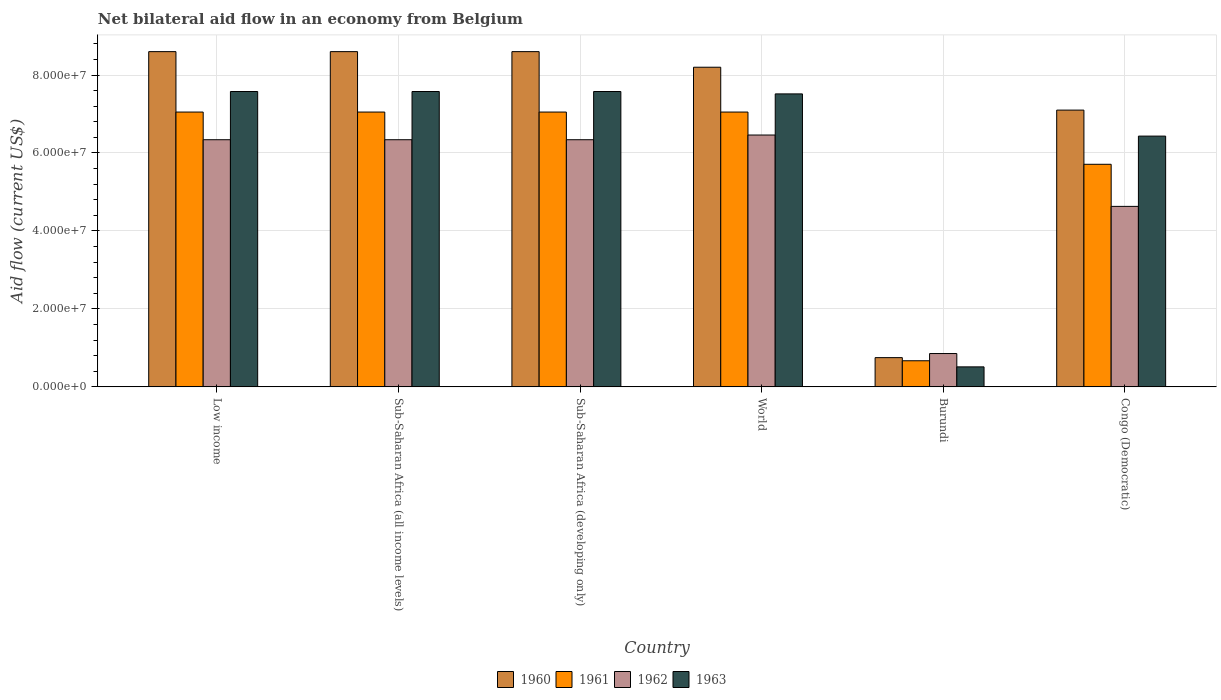How many different coloured bars are there?
Offer a terse response. 4. How many groups of bars are there?
Keep it short and to the point. 6. Are the number of bars per tick equal to the number of legend labels?
Your answer should be very brief. Yes. How many bars are there on the 3rd tick from the left?
Make the answer very short. 4. How many bars are there on the 3rd tick from the right?
Make the answer very short. 4. What is the label of the 2nd group of bars from the left?
Offer a terse response. Sub-Saharan Africa (all income levels). In how many cases, is the number of bars for a given country not equal to the number of legend labels?
Provide a short and direct response. 0. What is the net bilateral aid flow in 1963 in Congo (Democratic)?
Provide a short and direct response. 6.43e+07. Across all countries, what is the maximum net bilateral aid flow in 1963?
Your answer should be very brief. 7.58e+07. Across all countries, what is the minimum net bilateral aid flow in 1962?
Your response must be concise. 8.55e+06. In which country was the net bilateral aid flow in 1961 maximum?
Your answer should be compact. Low income. In which country was the net bilateral aid flow in 1962 minimum?
Keep it short and to the point. Burundi. What is the total net bilateral aid flow in 1963 in the graph?
Your answer should be very brief. 3.72e+08. What is the difference between the net bilateral aid flow in 1961 in Congo (Democratic) and that in Sub-Saharan Africa (developing only)?
Offer a very short reply. -1.34e+07. What is the difference between the net bilateral aid flow in 1960 in Congo (Democratic) and the net bilateral aid flow in 1963 in Low income?
Your response must be concise. -4.77e+06. What is the average net bilateral aid flow in 1962 per country?
Provide a succinct answer. 5.16e+07. What is the difference between the net bilateral aid flow of/in 1962 and net bilateral aid flow of/in 1963 in Low income?
Keep it short and to the point. -1.24e+07. What is the ratio of the net bilateral aid flow in 1960 in Sub-Saharan Africa (all income levels) to that in World?
Keep it short and to the point. 1.05. Is the difference between the net bilateral aid flow in 1962 in Low income and Sub-Saharan Africa (developing only) greater than the difference between the net bilateral aid flow in 1963 in Low income and Sub-Saharan Africa (developing only)?
Make the answer very short. No. What is the difference between the highest and the second highest net bilateral aid flow in 1962?
Give a very brief answer. 1.21e+06. What is the difference between the highest and the lowest net bilateral aid flow in 1961?
Ensure brevity in your answer.  6.38e+07. What does the 4th bar from the left in Low income represents?
Your answer should be compact. 1963. Is it the case that in every country, the sum of the net bilateral aid flow in 1961 and net bilateral aid flow in 1962 is greater than the net bilateral aid flow in 1963?
Offer a very short reply. Yes. How many bars are there?
Make the answer very short. 24. How many countries are there in the graph?
Your answer should be compact. 6. Does the graph contain any zero values?
Your answer should be very brief. No. Where does the legend appear in the graph?
Provide a succinct answer. Bottom center. How are the legend labels stacked?
Your answer should be compact. Horizontal. What is the title of the graph?
Provide a short and direct response. Net bilateral aid flow in an economy from Belgium. Does "2006" appear as one of the legend labels in the graph?
Make the answer very short. No. What is the Aid flow (current US$) in 1960 in Low income?
Offer a terse response. 8.60e+07. What is the Aid flow (current US$) of 1961 in Low income?
Make the answer very short. 7.05e+07. What is the Aid flow (current US$) in 1962 in Low income?
Offer a terse response. 6.34e+07. What is the Aid flow (current US$) of 1963 in Low income?
Offer a terse response. 7.58e+07. What is the Aid flow (current US$) in 1960 in Sub-Saharan Africa (all income levels)?
Your answer should be compact. 8.60e+07. What is the Aid flow (current US$) of 1961 in Sub-Saharan Africa (all income levels)?
Keep it short and to the point. 7.05e+07. What is the Aid flow (current US$) of 1962 in Sub-Saharan Africa (all income levels)?
Provide a succinct answer. 6.34e+07. What is the Aid flow (current US$) in 1963 in Sub-Saharan Africa (all income levels)?
Make the answer very short. 7.58e+07. What is the Aid flow (current US$) of 1960 in Sub-Saharan Africa (developing only)?
Offer a terse response. 8.60e+07. What is the Aid flow (current US$) in 1961 in Sub-Saharan Africa (developing only)?
Make the answer very short. 7.05e+07. What is the Aid flow (current US$) of 1962 in Sub-Saharan Africa (developing only)?
Your answer should be very brief. 6.34e+07. What is the Aid flow (current US$) of 1963 in Sub-Saharan Africa (developing only)?
Your answer should be compact. 7.58e+07. What is the Aid flow (current US$) of 1960 in World?
Ensure brevity in your answer.  8.20e+07. What is the Aid flow (current US$) in 1961 in World?
Give a very brief answer. 7.05e+07. What is the Aid flow (current US$) of 1962 in World?
Ensure brevity in your answer.  6.46e+07. What is the Aid flow (current US$) of 1963 in World?
Keep it short and to the point. 7.52e+07. What is the Aid flow (current US$) of 1960 in Burundi?
Keep it short and to the point. 7.50e+06. What is the Aid flow (current US$) of 1961 in Burundi?
Provide a succinct answer. 6.70e+06. What is the Aid flow (current US$) of 1962 in Burundi?
Your answer should be very brief. 8.55e+06. What is the Aid flow (current US$) of 1963 in Burundi?
Ensure brevity in your answer.  5.13e+06. What is the Aid flow (current US$) of 1960 in Congo (Democratic)?
Give a very brief answer. 7.10e+07. What is the Aid flow (current US$) in 1961 in Congo (Democratic)?
Provide a succinct answer. 5.71e+07. What is the Aid flow (current US$) in 1962 in Congo (Democratic)?
Provide a short and direct response. 4.63e+07. What is the Aid flow (current US$) of 1963 in Congo (Democratic)?
Provide a short and direct response. 6.43e+07. Across all countries, what is the maximum Aid flow (current US$) of 1960?
Provide a succinct answer. 8.60e+07. Across all countries, what is the maximum Aid flow (current US$) of 1961?
Your answer should be compact. 7.05e+07. Across all countries, what is the maximum Aid flow (current US$) in 1962?
Make the answer very short. 6.46e+07. Across all countries, what is the maximum Aid flow (current US$) in 1963?
Provide a short and direct response. 7.58e+07. Across all countries, what is the minimum Aid flow (current US$) of 1960?
Make the answer very short. 7.50e+06. Across all countries, what is the minimum Aid flow (current US$) of 1961?
Make the answer very short. 6.70e+06. Across all countries, what is the minimum Aid flow (current US$) of 1962?
Keep it short and to the point. 8.55e+06. Across all countries, what is the minimum Aid flow (current US$) in 1963?
Give a very brief answer. 5.13e+06. What is the total Aid flow (current US$) in 1960 in the graph?
Provide a succinct answer. 4.18e+08. What is the total Aid flow (current US$) in 1961 in the graph?
Give a very brief answer. 3.46e+08. What is the total Aid flow (current US$) in 1962 in the graph?
Ensure brevity in your answer.  3.10e+08. What is the total Aid flow (current US$) of 1963 in the graph?
Provide a short and direct response. 3.72e+08. What is the difference between the Aid flow (current US$) in 1960 in Low income and that in Sub-Saharan Africa (all income levels)?
Your response must be concise. 0. What is the difference between the Aid flow (current US$) in 1961 in Low income and that in Sub-Saharan Africa (all income levels)?
Your answer should be compact. 0. What is the difference between the Aid flow (current US$) in 1961 in Low income and that in Sub-Saharan Africa (developing only)?
Your answer should be compact. 0. What is the difference between the Aid flow (current US$) in 1961 in Low income and that in World?
Give a very brief answer. 0. What is the difference between the Aid flow (current US$) of 1962 in Low income and that in World?
Keep it short and to the point. -1.21e+06. What is the difference between the Aid flow (current US$) of 1960 in Low income and that in Burundi?
Offer a terse response. 7.85e+07. What is the difference between the Aid flow (current US$) in 1961 in Low income and that in Burundi?
Provide a short and direct response. 6.38e+07. What is the difference between the Aid flow (current US$) in 1962 in Low income and that in Burundi?
Provide a succinct answer. 5.48e+07. What is the difference between the Aid flow (current US$) in 1963 in Low income and that in Burundi?
Your answer should be compact. 7.06e+07. What is the difference between the Aid flow (current US$) of 1960 in Low income and that in Congo (Democratic)?
Provide a succinct answer. 1.50e+07. What is the difference between the Aid flow (current US$) of 1961 in Low income and that in Congo (Democratic)?
Your answer should be compact. 1.34e+07. What is the difference between the Aid flow (current US$) in 1962 in Low income and that in Congo (Democratic)?
Ensure brevity in your answer.  1.71e+07. What is the difference between the Aid flow (current US$) of 1963 in Low income and that in Congo (Democratic)?
Keep it short and to the point. 1.14e+07. What is the difference between the Aid flow (current US$) of 1960 in Sub-Saharan Africa (all income levels) and that in Sub-Saharan Africa (developing only)?
Your answer should be very brief. 0. What is the difference between the Aid flow (current US$) of 1961 in Sub-Saharan Africa (all income levels) and that in Sub-Saharan Africa (developing only)?
Offer a very short reply. 0. What is the difference between the Aid flow (current US$) of 1962 in Sub-Saharan Africa (all income levels) and that in World?
Keep it short and to the point. -1.21e+06. What is the difference between the Aid flow (current US$) in 1960 in Sub-Saharan Africa (all income levels) and that in Burundi?
Provide a short and direct response. 7.85e+07. What is the difference between the Aid flow (current US$) of 1961 in Sub-Saharan Africa (all income levels) and that in Burundi?
Give a very brief answer. 6.38e+07. What is the difference between the Aid flow (current US$) in 1962 in Sub-Saharan Africa (all income levels) and that in Burundi?
Provide a short and direct response. 5.48e+07. What is the difference between the Aid flow (current US$) of 1963 in Sub-Saharan Africa (all income levels) and that in Burundi?
Give a very brief answer. 7.06e+07. What is the difference between the Aid flow (current US$) in 1960 in Sub-Saharan Africa (all income levels) and that in Congo (Democratic)?
Offer a terse response. 1.50e+07. What is the difference between the Aid flow (current US$) in 1961 in Sub-Saharan Africa (all income levels) and that in Congo (Democratic)?
Make the answer very short. 1.34e+07. What is the difference between the Aid flow (current US$) in 1962 in Sub-Saharan Africa (all income levels) and that in Congo (Democratic)?
Provide a succinct answer. 1.71e+07. What is the difference between the Aid flow (current US$) in 1963 in Sub-Saharan Africa (all income levels) and that in Congo (Democratic)?
Keep it short and to the point. 1.14e+07. What is the difference between the Aid flow (current US$) of 1960 in Sub-Saharan Africa (developing only) and that in World?
Make the answer very short. 4.00e+06. What is the difference between the Aid flow (current US$) in 1961 in Sub-Saharan Africa (developing only) and that in World?
Keep it short and to the point. 0. What is the difference between the Aid flow (current US$) of 1962 in Sub-Saharan Africa (developing only) and that in World?
Provide a succinct answer. -1.21e+06. What is the difference between the Aid flow (current US$) in 1963 in Sub-Saharan Africa (developing only) and that in World?
Keep it short and to the point. 6.10e+05. What is the difference between the Aid flow (current US$) of 1960 in Sub-Saharan Africa (developing only) and that in Burundi?
Ensure brevity in your answer.  7.85e+07. What is the difference between the Aid flow (current US$) in 1961 in Sub-Saharan Africa (developing only) and that in Burundi?
Provide a succinct answer. 6.38e+07. What is the difference between the Aid flow (current US$) of 1962 in Sub-Saharan Africa (developing only) and that in Burundi?
Your answer should be compact. 5.48e+07. What is the difference between the Aid flow (current US$) in 1963 in Sub-Saharan Africa (developing only) and that in Burundi?
Provide a short and direct response. 7.06e+07. What is the difference between the Aid flow (current US$) in 1960 in Sub-Saharan Africa (developing only) and that in Congo (Democratic)?
Your answer should be compact. 1.50e+07. What is the difference between the Aid flow (current US$) in 1961 in Sub-Saharan Africa (developing only) and that in Congo (Democratic)?
Provide a succinct answer. 1.34e+07. What is the difference between the Aid flow (current US$) of 1962 in Sub-Saharan Africa (developing only) and that in Congo (Democratic)?
Make the answer very short. 1.71e+07. What is the difference between the Aid flow (current US$) of 1963 in Sub-Saharan Africa (developing only) and that in Congo (Democratic)?
Give a very brief answer. 1.14e+07. What is the difference between the Aid flow (current US$) in 1960 in World and that in Burundi?
Provide a short and direct response. 7.45e+07. What is the difference between the Aid flow (current US$) in 1961 in World and that in Burundi?
Provide a succinct answer. 6.38e+07. What is the difference between the Aid flow (current US$) of 1962 in World and that in Burundi?
Keep it short and to the point. 5.61e+07. What is the difference between the Aid flow (current US$) in 1963 in World and that in Burundi?
Provide a short and direct response. 7.00e+07. What is the difference between the Aid flow (current US$) of 1960 in World and that in Congo (Democratic)?
Your answer should be compact. 1.10e+07. What is the difference between the Aid flow (current US$) of 1961 in World and that in Congo (Democratic)?
Your answer should be very brief. 1.34e+07. What is the difference between the Aid flow (current US$) in 1962 in World and that in Congo (Democratic)?
Provide a short and direct response. 1.83e+07. What is the difference between the Aid flow (current US$) of 1963 in World and that in Congo (Democratic)?
Ensure brevity in your answer.  1.08e+07. What is the difference between the Aid flow (current US$) of 1960 in Burundi and that in Congo (Democratic)?
Your answer should be compact. -6.35e+07. What is the difference between the Aid flow (current US$) of 1961 in Burundi and that in Congo (Democratic)?
Keep it short and to the point. -5.04e+07. What is the difference between the Aid flow (current US$) in 1962 in Burundi and that in Congo (Democratic)?
Keep it short and to the point. -3.78e+07. What is the difference between the Aid flow (current US$) of 1963 in Burundi and that in Congo (Democratic)?
Your answer should be very brief. -5.92e+07. What is the difference between the Aid flow (current US$) in 1960 in Low income and the Aid flow (current US$) in 1961 in Sub-Saharan Africa (all income levels)?
Your answer should be very brief. 1.55e+07. What is the difference between the Aid flow (current US$) in 1960 in Low income and the Aid flow (current US$) in 1962 in Sub-Saharan Africa (all income levels)?
Make the answer very short. 2.26e+07. What is the difference between the Aid flow (current US$) in 1960 in Low income and the Aid flow (current US$) in 1963 in Sub-Saharan Africa (all income levels)?
Offer a very short reply. 1.02e+07. What is the difference between the Aid flow (current US$) of 1961 in Low income and the Aid flow (current US$) of 1962 in Sub-Saharan Africa (all income levels)?
Offer a terse response. 7.10e+06. What is the difference between the Aid flow (current US$) in 1961 in Low income and the Aid flow (current US$) in 1963 in Sub-Saharan Africa (all income levels)?
Offer a terse response. -5.27e+06. What is the difference between the Aid flow (current US$) of 1962 in Low income and the Aid flow (current US$) of 1963 in Sub-Saharan Africa (all income levels)?
Your response must be concise. -1.24e+07. What is the difference between the Aid flow (current US$) in 1960 in Low income and the Aid flow (current US$) in 1961 in Sub-Saharan Africa (developing only)?
Give a very brief answer. 1.55e+07. What is the difference between the Aid flow (current US$) in 1960 in Low income and the Aid flow (current US$) in 1962 in Sub-Saharan Africa (developing only)?
Provide a succinct answer. 2.26e+07. What is the difference between the Aid flow (current US$) of 1960 in Low income and the Aid flow (current US$) of 1963 in Sub-Saharan Africa (developing only)?
Give a very brief answer. 1.02e+07. What is the difference between the Aid flow (current US$) of 1961 in Low income and the Aid flow (current US$) of 1962 in Sub-Saharan Africa (developing only)?
Provide a short and direct response. 7.10e+06. What is the difference between the Aid flow (current US$) of 1961 in Low income and the Aid flow (current US$) of 1963 in Sub-Saharan Africa (developing only)?
Your answer should be compact. -5.27e+06. What is the difference between the Aid flow (current US$) of 1962 in Low income and the Aid flow (current US$) of 1963 in Sub-Saharan Africa (developing only)?
Provide a short and direct response. -1.24e+07. What is the difference between the Aid flow (current US$) of 1960 in Low income and the Aid flow (current US$) of 1961 in World?
Provide a succinct answer. 1.55e+07. What is the difference between the Aid flow (current US$) in 1960 in Low income and the Aid flow (current US$) in 1962 in World?
Your response must be concise. 2.14e+07. What is the difference between the Aid flow (current US$) in 1960 in Low income and the Aid flow (current US$) in 1963 in World?
Your answer should be very brief. 1.08e+07. What is the difference between the Aid flow (current US$) in 1961 in Low income and the Aid flow (current US$) in 1962 in World?
Your response must be concise. 5.89e+06. What is the difference between the Aid flow (current US$) of 1961 in Low income and the Aid flow (current US$) of 1963 in World?
Offer a terse response. -4.66e+06. What is the difference between the Aid flow (current US$) in 1962 in Low income and the Aid flow (current US$) in 1963 in World?
Make the answer very short. -1.18e+07. What is the difference between the Aid flow (current US$) of 1960 in Low income and the Aid flow (current US$) of 1961 in Burundi?
Give a very brief answer. 7.93e+07. What is the difference between the Aid flow (current US$) of 1960 in Low income and the Aid flow (current US$) of 1962 in Burundi?
Your response must be concise. 7.74e+07. What is the difference between the Aid flow (current US$) of 1960 in Low income and the Aid flow (current US$) of 1963 in Burundi?
Your answer should be compact. 8.09e+07. What is the difference between the Aid flow (current US$) in 1961 in Low income and the Aid flow (current US$) in 1962 in Burundi?
Offer a very short reply. 6.20e+07. What is the difference between the Aid flow (current US$) of 1961 in Low income and the Aid flow (current US$) of 1963 in Burundi?
Ensure brevity in your answer.  6.54e+07. What is the difference between the Aid flow (current US$) of 1962 in Low income and the Aid flow (current US$) of 1963 in Burundi?
Make the answer very short. 5.83e+07. What is the difference between the Aid flow (current US$) of 1960 in Low income and the Aid flow (current US$) of 1961 in Congo (Democratic)?
Your answer should be very brief. 2.89e+07. What is the difference between the Aid flow (current US$) in 1960 in Low income and the Aid flow (current US$) in 1962 in Congo (Democratic)?
Offer a terse response. 3.97e+07. What is the difference between the Aid flow (current US$) in 1960 in Low income and the Aid flow (current US$) in 1963 in Congo (Democratic)?
Your response must be concise. 2.17e+07. What is the difference between the Aid flow (current US$) of 1961 in Low income and the Aid flow (current US$) of 1962 in Congo (Democratic)?
Make the answer very short. 2.42e+07. What is the difference between the Aid flow (current US$) in 1961 in Low income and the Aid flow (current US$) in 1963 in Congo (Democratic)?
Provide a succinct answer. 6.17e+06. What is the difference between the Aid flow (current US$) in 1962 in Low income and the Aid flow (current US$) in 1963 in Congo (Democratic)?
Offer a terse response. -9.30e+05. What is the difference between the Aid flow (current US$) of 1960 in Sub-Saharan Africa (all income levels) and the Aid flow (current US$) of 1961 in Sub-Saharan Africa (developing only)?
Ensure brevity in your answer.  1.55e+07. What is the difference between the Aid flow (current US$) in 1960 in Sub-Saharan Africa (all income levels) and the Aid flow (current US$) in 1962 in Sub-Saharan Africa (developing only)?
Make the answer very short. 2.26e+07. What is the difference between the Aid flow (current US$) of 1960 in Sub-Saharan Africa (all income levels) and the Aid flow (current US$) of 1963 in Sub-Saharan Africa (developing only)?
Make the answer very short. 1.02e+07. What is the difference between the Aid flow (current US$) of 1961 in Sub-Saharan Africa (all income levels) and the Aid flow (current US$) of 1962 in Sub-Saharan Africa (developing only)?
Provide a succinct answer. 7.10e+06. What is the difference between the Aid flow (current US$) of 1961 in Sub-Saharan Africa (all income levels) and the Aid flow (current US$) of 1963 in Sub-Saharan Africa (developing only)?
Offer a terse response. -5.27e+06. What is the difference between the Aid flow (current US$) of 1962 in Sub-Saharan Africa (all income levels) and the Aid flow (current US$) of 1963 in Sub-Saharan Africa (developing only)?
Keep it short and to the point. -1.24e+07. What is the difference between the Aid flow (current US$) of 1960 in Sub-Saharan Africa (all income levels) and the Aid flow (current US$) of 1961 in World?
Provide a succinct answer. 1.55e+07. What is the difference between the Aid flow (current US$) in 1960 in Sub-Saharan Africa (all income levels) and the Aid flow (current US$) in 1962 in World?
Your answer should be compact. 2.14e+07. What is the difference between the Aid flow (current US$) in 1960 in Sub-Saharan Africa (all income levels) and the Aid flow (current US$) in 1963 in World?
Make the answer very short. 1.08e+07. What is the difference between the Aid flow (current US$) of 1961 in Sub-Saharan Africa (all income levels) and the Aid flow (current US$) of 1962 in World?
Your response must be concise. 5.89e+06. What is the difference between the Aid flow (current US$) of 1961 in Sub-Saharan Africa (all income levels) and the Aid flow (current US$) of 1963 in World?
Provide a succinct answer. -4.66e+06. What is the difference between the Aid flow (current US$) in 1962 in Sub-Saharan Africa (all income levels) and the Aid flow (current US$) in 1963 in World?
Provide a short and direct response. -1.18e+07. What is the difference between the Aid flow (current US$) in 1960 in Sub-Saharan Africa (all income levels) and the Aid flow (current US$) in 1961 in Burundi?
Offer a very short reply. 7.93e+07. What is the difference between the Aid flow (current US$) in 1960 in Sub-Saharan Africa (all income levels) and the Aid flow (current US$) in 1962 in Burundi?
Offer a terse response. 7.74e+07. What is the difference between the Aid flow (current US$) of 1960 in Sub-Saharan Africa (all income levels) and the Aid flow (current US$) of 1963 in Burundi?
Offer a very short reply. 8.09e+07. What is the difference between the Aid flow (current US$) in 1961 in Sub-Saharan Africa (all income levels) and the Aid flow (current US$) in 1962 in Burundi?
Keep it short and to the point. 6.20e+07. What is the difference between the Aid flow (current US$) of 1961 in Sub-Saharan Africa (all income levels) and the Aid flow (current US$) of 1963 in Burundi?
Ensure brevity in your answer.  6.54e+07. What is the difference between the Aid flow (current US$) in 1962 in Sub-Saharan Africa (all income levels) and the Aid flow (current US$) in 1963 in Burundi?
Your response must be concise. 5.83e+07. What is the difference between the Aid flow (current US$) of 1960 in Sub-Saharan Africa (all income levels) and the Aid flow (current US$) of 1961 in Congo (Democratic)?
Provide a succinct answer. 2.89e+07. What is the difference between the Aid flow (current US$) of 1960 in Sub-Saharan Africa (all income levels) and the Aid flow (current US$) of 1962 in Congo (Democratic)?
Offer a terse response. 3.97e+07. What is the difference between the Aid flow (current US$) of 1960 in Sub-Saharan Africa (all income levels) and the Aid flow (current US$) of 1963 in Congo (Democratic)?
Provide a succinct answer. 2.17e+07. What is the difference between the Aid flow (current US$) of 1961 in Sub-Saharan Africa (all income levels) and the Aid flow (current US$) of 1962 in Congo (Democratic)?
Your answer should be compact. 2.42e+07. What is the difference between the Aid flow (current US$) of 1961 in Sub-Saharan Africa (all income levels) and the Aid flow (current US$) of 1963 in Congo (Democratic)?
Your answer should be very brief. 6.17e+06. What is the difference between the Aid flow (current US$) of 1962 in Sub-Saharan Africa (all income levels) and the Aid flow (current US$) of 1963 in Congo (Democratic)?
Offer a terse response. -9.30e+05. What is the difference between the Aid flow (current US$) in 1960 in Sub-Saharan Africa (developing only) and the Aid flow (current US$) in 1961 in World?
Give a very brief answer. 1.55e+07. What is the difference between the Aid flow (current US$) of 1960 in Sub-Saharan Africa (developing only) and the Aid flow (current US$) of 1962 in World?
Make the answer very short. 2.14e+07. What is the difference between the Aid flow (current US$) of 1960 in Sub-Saharan Africa (developing only) and the Aid flow (current US$) of 1963 in World?
Provide a succinct answer. 1.08e+07. What is the difference between the Aid flow (current US$) of 1961 in Sub-Saharan Africa (developing only) and the Aid flow (current US$) of 1962 in World?
Give a very brief answer. 5.89e+06. What is the difference between the Aid flow (current US$) of 1961 in Sub-Saharan Africa (developing only) and the Aid flow (current US$) of 1963 in World?
Make the answer very short. -4.66e+06. What is the difference between the Aid flow (current US$) of 1962 in Sub-Saharan Africa (developing only) and the Aid flow (current US$) of 1963 in World?
Provide a short and direct response. -1.18e+07. What is the difference between the Aid flow (current US$) in 1960 in Sub-Saharan Africa (developing only) and the Aid flow (current US$) in 1961 in Burundi?
Your answer should be compact. 7.93e+07. What is the difference between the Aid flow (current US$) of 1960 in Sub-Saharan Africa (developing only) and the Aid flow (current US$) of 1962 in Burundi?
Offer a very short reply. 7.74e+07. What is the difference between the Aid flow (current US$) of 1960 in Sub-Saharan Africa (developing only) and the Aid flow (current US$) of 1963 in Burundi?
Offer a terse response. 8.09e+07. What is the difference between the Aid flow (current US$) in 1961 in Sub-Saharan Africa (developing only) and the Aid flow (current US$) in 1962 in Burundi?
Provide a succinct answer. 6.20e+07. What is the difference between the Aid flow (current US$) of 1961 in Sub-Saharan Africa (developing only) and the Aid flow (current US$) of 1963 in Burundi?
Make the answer very short. 6.54e+07. What is the difference between the Aid flow (current US$) of 1962 in Sub-Saharan Africa (developing only) and the Aid flow (current US$) of 1963 in Burundi?
Keep it short and to the point. 5.83e+07. What is the difference between the Aid flow (current US$) in 1960 in Sub-Saharan Africa (developing only) and the Aid flow (current US$) in 1961 in Congo (Democratic)?
Your answer should be compact. 2.89e+07. What is the difference between the Aid flow (current US$) in 1960 in Sub-Saharan Africa (developing only) and the Aid flow (current US$) in 1962 in Congo (Democratic)?
Ensure brevity in your answer.  3.97e+07. What is the difference between the Aid flow (current US$) of 1960 in Sub-Saharan Africa (developing only) and the Aid flow (current US$) of 1963 in Congo (Democratic)?
Your response must be concise. 2.17e+07. What is the difference between the Aid flow (current US$) of 1961 in Sub-Saharan Africa (developing only) and the Aid flow (current US$) of 1962 in Congo (Democratic)?
Offer a terse response. 2.42e+07. What is the difference between the Aid flow (current US$) in 1961 in Sub-Saharan Africa (developing only) and the Aid flow (current US$) in 1963 in Congo (Democratic)?
Provide a short and direct response. 6.17e+06. What is the difference between the Aid flow (current US$) in 1962 in Sub-Saharan Africa (developing only) and the Aid flow (current US$) in 1963 in Congo (Democratic)?
Give a very brief answer. -9.30e+05. What is the difference between the Aid flow (current US$) of 1960 in World and the Aid flow (current US$) of 1961 in Burundi?
Ensure brevity in your answer.  7.53e+07. What is the difference between the Aid flow (current US$) of 1960 in World and the Aid flow (current US$) of 1962 in Burundi?
Give a very brief answer. 7.34e+07. What is the difference between the Aid flow (current US$) in 1960 in World and the Aid flow (current US$) in 1963 in Burundi?
Your answer should be very brief. 7.69e+07. What is the difference between the Aid flow (current US$) in 1961 in World and the Aid flow (current US$) in 1962 in Burundi?
Your response must be concise. 6.20e+07. What is the difference between the Aid flow (current US$) of 1961 in World and the Aid flow (current US$) of 1963 in Burundi?
Your answer should be very brief. 6.54e+07. What is the difference between the Aid flow (current US$) in 1962 in World and the Aid flow (current US$) in 1963 in Burundi?
Your answer should be compact. 5.95e+07. What is the difference between the Aid flow (current US$) in 1960 in World and the Aid flow (current US$) in 1961 in Congo (Democratic)?
Your response must be concise. 2.49e+07. What is the difference between the Aid flow (current US$) in 1960 in World and the Aid flow (current US$) in 1962 in Congo (Democratic)?
Keep it short and to the point. 3.57e+07. What is the difference between the Aid flow (current US$) of 1960 in World and the Aid flow (current US$) of 1963 in Congo (Democratic)?
Offer a terse response. 1.77e+07. What is the difference between the Aid flow (current US$) in 1961 in World and the Aid flow (current US$) in 1962 in Congo (Democratic)?
Make the answer very short. 2.42e+07. What is the difference between the Aid flow (current US$) in 1961 in World and the Aid flow (current US$) in 1963 in Congo (Democratic)?
Your response must be concise. 6.17e+06. What is the difference between the Aid flow (current US$) in 1960 in Burundi and the Aid flow (current US$) in 1961 in Congo (Democratic)?
Provide a succinct answer. -4.96e+07. What is the difference between the Aid flow (current US$) in 1960 in Burundi and the Aid flow (current US$) in 1962 in Congo (Democratic)?
Offer a very short reply. -3.88e+07. What is the difference between the Aid flow (current US$) of 1960 in Burundi and the Aid flow (current US$) of 1963 in Congo (Democratic)?
Your answer should be very brief. -5.68e+07. What is the difference between the Aid flow (current US$) of 1961 in Burundi and the Aid flow (current US$) of 1962 in Congo (Democratic)?
Your answer should be compact. -3.96e+07. What is the difference between the Aid flow (current US$) of 1961 in Burundi and the Aid flow (current US$) of 1963 in Congo (Democratic)?
Keep it short and to the point. -5.76e+07. What is the difference between the Aid flow (current US$) of 1962 in Burundi and the Aid flow (current US$) of 1963 in Congo (Democratic)?
Give a very brief answer. -5.58e+07. What is the average Aid flow (current US$) of 1960 per country?
Your answer should be compact. 6.98e+07. What is the average Aid flow (current US$) of 1961 per country?
Ensure brevity in your answer.  5.76e+07. What is the average Aid flow (current US$) of 1962 per country?
Offer a very short reply. 5.16e+07. What is the average Aid flow (current US$) in 1963 per country?
Provide a short and direct response. 6.20e+07. What is the difference between the Aid flow (current US$) in 1960 and Aid flow (current US$) in 1961 in Low income?
Provide a short and direct response. 1.55e+07. What is the difference between the Aid flow (current US$) of 1960 and Aid flow (current US$) of 1962 in Low income?
Ensure brevity in your answer.  2.26e+07. What is the difference between the Aid flow (current US$) of 1960 and Aid flow (current US$) of 1963 in Low income?
Provide a short and direct response. 1.02e+07. What is the difference between the Aid flow (current US$) of 1961 and Aid flow (current US$) of 1962 in Low income?
Your answer should be compact. 7.10e+06. What is the difference between the Aid flow (current US$) of 1961 and Aid flow (current US$) of 1963 in Low income?
Provide a short and direct response. -5.27e+06. What is the difference between the Aid flow (current US$) in 1962 and Aid flow (current US$) in 1963 in Low income?
Keep it short and to the point. -1.24e+07. What is the difference between the Aid flow (current US$) of 1960 and Aid flow (current US$) of 1961 in Sub-Saharan Africa (all income levels)?
Keep it short and to the point. 1.55e+07. What is the difference between the Aid flow (current US$) in 1960 and Aid flow (current US$) in 1962 in Sub-Saharan Africa (all income levels)?
Your response must be concise. 2.26e+07. What is the difference between the Aid flow (current US$) of 1960 and Aid flow (current US$) of 1963 in Sub-Saharan Africa (all income levels)?
Offer a terse response. 1.02e+07. What is the difference between the Aid flow (current US$) of 1961 and Aid flow (current US$) of 1962 in Sub-Saharan Africa (all income levels)?
Your answer should be compact. 7.10e+06. What is the difference between the Aid flow (current US$) in 1961 and Aid flow (current US$) in 1963 in Sub-Saharan Africa (all income levels)?
Provide a succinct answer. -5.27e+06. What is the difference between the Aid flow (current US$) in 1962 and Aid flow (current US$) in 1963 in Sub-Saharan Africa (all income levels)?
Give a very brief answer. -1.24e+07. What is the difference between the Aid flow (current US$) of 1960 and Aid flow (current US$) of 1961 in Sub-Saharan Africa (developing only)?
Offer a very short reply. 1.55e+07. What is the difference between the Aid flow (current US$) in 1960 and Aid flow (current US$) in 1962 in Sub-Saharan Africa (developing only)?
Ensure brevity in your answer.  2.26e+07. What is the difference between the Aid flow (current US$) in 1960 and Aid flow (current US$) in 1963 in Sub-Saharan Africa (developing only)?
Provide a succinct answer. 1.02e+07. What is the difference between the Aid flow (current US$) in 1961 and Aid flow (current US$) in 1962 in Sub-Saharan Africa (developing only)?
Provide a short and direct response. 7.10e+06. What is the difference between the Aid flow (current US$) in 1961 and Aid flow (current US$) in 1963 in Sub-Saharan Africa (developing only)?
Offer a very short reply. -5.27e+06. What is the difference between the Aid flow (current US$) of 1962 and Aid flow (current US$) of 1963 in Sub-Saharan Africa (developing only)?
Provide a succinct answer. -1.24e+07. What is the difference between the Aid flow (current US$) of 1960 and Aid flow (current US$) of 1961 in World?
Ensure brevity in your answer.  1.15e+07. What is the difference between the Aid flow (current US$) of 1960 and Aid flow (current US$) of 1962 in World?
Your response must be concise. 1.74e+07. What is the difference between the Aid flow (current US$) in 1960 and Aid flow (current US$) in 1963 in World?
Offer a terse response. 6.84e+06. What is the difference between the Aid flow (current US$) in 1961 and Aid flow (current US$) in 1962 in World?
Your response must be concise. 5.89e+06. What is the difference between the Aid flow (current US$) in 1961 and Aid flow (current US$) in 1963 in World?
Offer a very short reply. -4.66e+06. What is the difference between the Aid flow (current US$) of 1962 and Aid flow (current US$) of 1963 in World?
Give a very brief answer. -1.06e+07. What is the difference between the Aid flow (current US$) in 1960 and Aid flow (current US$) in 1962 in Burundi?
Your answer should be very brief. -1.05e+06. What is the difference between the Aid flow (current US$) of 1960 and Aid flow (current US$) of 1963 in Burundi?
Keep it short and to the point. 2.37e+06. What is the difference between the Aid flow (current US$) in 1961 and Aid flow (current US$) in 1962 in Burundi?
Your response must be concise. -1.85e+06. What is the difference between the Aid flow (current US$) in 1961 and Aid flow (current US$) in 1963 in Burundi?
Provide a succinct answer. 1.57e+06. What is the difference between the Aid flow (current US$) in 1962 and Aid flow (current US$) in 1963 in Burundi?
Offer a very short reply. 3.42e+06. What is the difference between the Aid flow (current US$) in 1960 and Aid flow (current US$) in 1961 in Congo (Democratic)?
Keep it short and to the point. 1.39e+07. What is the difference between the Aid flow (current US$) of 1960 and Aid flow (current US$) of 1962 in Congo (Democratic)?
Ensure brevity in your answer.  2.47e+07. What is the difference between the Aid flow (current US$) in 1960 and Aid flow (current US$) in 1963 in Congo (Democratic)?
Keep it short and to the point. 6.67e+06. What is the difference between the Aid flow (current US$) of 1961 and Aid flow (current US$) of 1962 in Congo (Democratic)?
Ensure brevity in your answer.  1.08e+07. What is the difference between the Aid flow (current US$) in 1961 and Aid flow (current US$) in 1963 in Congo (Democratic)?
Offer a terse response. -7.23e+06. What is the difference between the Aid flow (current US$) in 1962 and Aid flow (current US$) in 1963 in Congo (Democratic)?
Your response must be concise. -1.80e+07. What is the ratio of the Aid flow (current US$) of 1960 in Low income to that in Sub-Saharan Africa (all income levels)?
Your answer should be very brief. 1. What is the ratio of the Aid flow (current US$) of 1962 in Low income to that in Sub-Saharan Africa (all income levels)?
Make the answer very short. 1. What is the ratio of the Aid flow (current US$) of 1960 in Low income to that in Sub-Saharan Africa (developing only)?
Give a very brief answer. 1. What is the ratio of the Aid flow (current US$) in 1963 in Low income to that in Sub-Saharan Africa (developing only)?
Your answer should be compact. 1. What is the ratio of the Aid flow (current US$) of 1960 in Low income to that in World?
Offer a terse response. 1.05. What is the ratio of the Aid flow (current US$) of 1962 in Low income to that in World?
Ensure brevity in your answer.  0.98. What is the ratio of the Aid flow (current US$) of 1960 in Low income to that in Burundi?
Provide a short and direct response. 11.47. What is the ratio of the Aid flow (current US$) in 1961 in Low income to that in Burundi?
Provide a short and direct response. 10.52. What is the ratio of the Aid flow (current US$) in 1962 in Low income to that in Burundi?
Give a very brief answer. 7.42. What is the ratio of the Aid flow (current US$) of 1963 in Low income to that in Burundi?
Provide a succinct answer. 14.77. What is the ratio of the Aid flow (current US$) in 1960 in Low income to that in Congo (Democratic)?
Make the answer very short. 1.21. What is the ratio of the Aid flow (current US$) in 1961 in Low income to that in Congo (Democratic)?
Ensure brevity in your answer.  1.23. What is the ratio of the Aid flow (current US$) in 1962 in Low income to that in Congo (Democratic)?
Your response must be concise. 1.37. What is the ratio of the Aid flow (current US$) in 1963 in Low income to that in Congo (Democratic)?
Ensure brevity in your answer.  1.18. What is the ratio of the Aid flow (current US$) of 1961 in Sub-Saharan Africa (all income levels) to that in Sub-Saharan Africa (developing only)?
Your response must be concise. 1. What is the ratio of the Aid flow (current US$) in 1963 in Sub-Saharan Africa (all income levels) to that in Sub-Saharan Africa (developing only)?
Offer a very short reply. 1. What is the ratio of the Aid flow (current US$) of 1960 in Sub-Saharan Africa (all income levels) to that in World?
Keep it short and to the point. 1.05. What is the ratio of the Aid flow (current US$) in 1961 in Sub-Saharan Africa (all income levels) to that in World?
Offer a terse response. 1. What is the ratio of the Aid flow (current US$) of 1962 in Sub-Saharan Africa (all income levels) to that in World?
Provide a succinct answer. 0.98. What is the ratio of the Aid flow (current US$) of 1963 in Sub-Saharan Africa (all income levels) to that in World?
Ensure brevity in your answer.  1.01. What is the ratio of the Aid flow (current US$) in 1960 in Sub-Saharan Africa (all income levels) to that in Burundi?
Your answer should be compact. 11.47. What is the ratio of the Aid flow (current US$) of 1961 in Sub-Saharan Africa (all income levels) to that in Burundi?
Ensure brevity in your answer.  10.52. What is the ratio of the Aid flow (current US$) in 1962 in Sub-Saharan Africa (all income levels) to that in Burundi?
Give a very brief answer. 7.42. What is the ratio of the Aid flow (current US$) of 1963 in Sub-Saharan Africa (all income levels) to that in Burundi?
Keep it short and to the point. 14.77. What is the ratio of the Aid flow (current US$) in 1960 in Sub-Saharan Africa (all income levels) to that in Congo (Democratic)?
Keep it short and to the point. 1.21. What is the ratio of the Aid flow (current US$) in 1961 in Sub-Saharan Africa (all income levels) to that in Congo (Democratic)?
Your response must be concise. 1.23. What is the ratio of the Aid flow (current US$) in 1962 in Sub-Saharan Africa (all income levels) to that in Congo (Democratic)?
Ensure brevity in your answer.  1.37. What is the ratio of the Aid flow (current US$) in 1963 in Sub-Saharan Africa (all income levels) to that in Congo (Democratic)?
Offer a very short reply. 1.18. What is the ratio of the Aid flow (current US$) in 1960 in Sub-Saharan Africa (developing only) to that in World?
Your answer should be very brief. 1.05. What is the ratio of the Aid flow (current US$) of 1962 in Sub-Saharan Africa (developing only) to that in World?
Keep it short and to the point. 0.98. What is the ratio of the Aid flow (current US$) in 1963 in Sub-Saharan Africa (developing only) to that in World?
Keep it short and to the point. 1.01. What is the ratio of the Aid flow (current US$) in 1960 in Sub-Saharan Africa (developing only) to that in Burundi?
Offer a very short reply. 11.47. What is the ratio of the Aid flow (current US$) of 1961 in Sub-Saharan Africa (developing only) to that in Burundi?
Keep it short and to the point. 10.52. What is the ratio of the Aid flow (current US$) in 1962 in Sub-Saharan Africa (developing only) to that in Burundi?
Make the answer very short. 7.42. What is the ratio of the Aid flow (current US$) of 1963 in Sub-Saharan Africa (developing only) to that in Burundi?
Your response must be concise. 14.77. What is the ratio of the Aid flow (current US$) of 1960 in Sub-Saharan Africa (developing only) to that in Congo (Democratic)?
Provide a succinct answer. 1.21. What is the ratio of the Aid flow (current US$) in 1961 in Sub-Saharan Africa (developing only) to that in Congo (Democratic)?
Provide a succinct answer. 1.23. What is the ratio of the Aid flow (current US$) in 1962 in Sub-Saharan Africa (developing only) to that in Congo (Democratic)?
Make the answer very short. 1.37. What is the ratio of the Aid flow (current US$) in 1963 in Sub-Saharan Africa (developing only) to that in Congo (Democratic)?
Provide a short and direct response. 1.18. What is the ratio of the Aid flow (current US$) of 1960 in World to that in Burundi?
Ensure brevity in your answer.  10.93. What is the ratio of the Aid flow (current US$) of 1961 in World to that in Burundi?
Offer a terse response. 10.52. What is the ratio of the Aid flow (current US$) of 1962 in World to that in Burundi?
Make the answer very short. 7.56. What is the ratio of the Aid flow (current US$) in 1963 in World to that in Burundi?
Keep it short and to the point. 14.65. What is the ratio of the Aid flow (current US$) in 1960 in World to that in Congo (Democratic)?
Provide a succinct answer. 1.15. What is the ratio of the Aid flow (current US$) in 1961 in World to that in Congo (Democratic)?
Provide a succinct answer. 1.23. What is the ratio of the Aid flow (current US$) in 1962 in World to that in Congo (Democratic)?
Your response must be concise. 1.4. What is the ratio of the Aid flow (current US$) in 1963 in World to that in Congo (Democratic)?
Make the answer very short. 1.17. What is the ratio of the Aid flow (current US$) in 1960 in Burundi to that in Congo (Democratic)?
Ensure brevity in your answer.  0.11. What is the ratio of the Aid flow (current US$) of 1961 in Burundi to that in Congo (Democratic)?
Your response must be concise. 0.12. What is the ratio of the Aid flow (current US$) in 1962 in Burundi to that in Congo (Democratic)?
Ensure brevity in your answer.  0.18. What is the ratio of the Aid flow (current US$) of 1963 in Burundi to that in Congo (Democratic)?
Give a very brief answer. 0.08. What is the difference between the highest and the second highest Aid flow (current US$) of 1962?
Your answer should be compact. 1.21e+06. What is the difference between the highest and the second highest Aid flow (current US$) in 1963?
Make the answer very short. 0. What is the difference between the highest and the lowest Aid flow (current US$) of 1960?
Provide a short and direct response. 7.85e+07. What is the difference between the highest and the lowest Aid flow (current US$) in 1961?
Offer a terse response. 6.38e+07. What is the difference between the highest and the lowest Aid flow (current US$) in 1962?
Offer a terse response. 5.61e+07. What is the difference between the highest and the lowest Aid flow (current US$) of 1963?
Your answer should be very brief. 7.06e+07. 